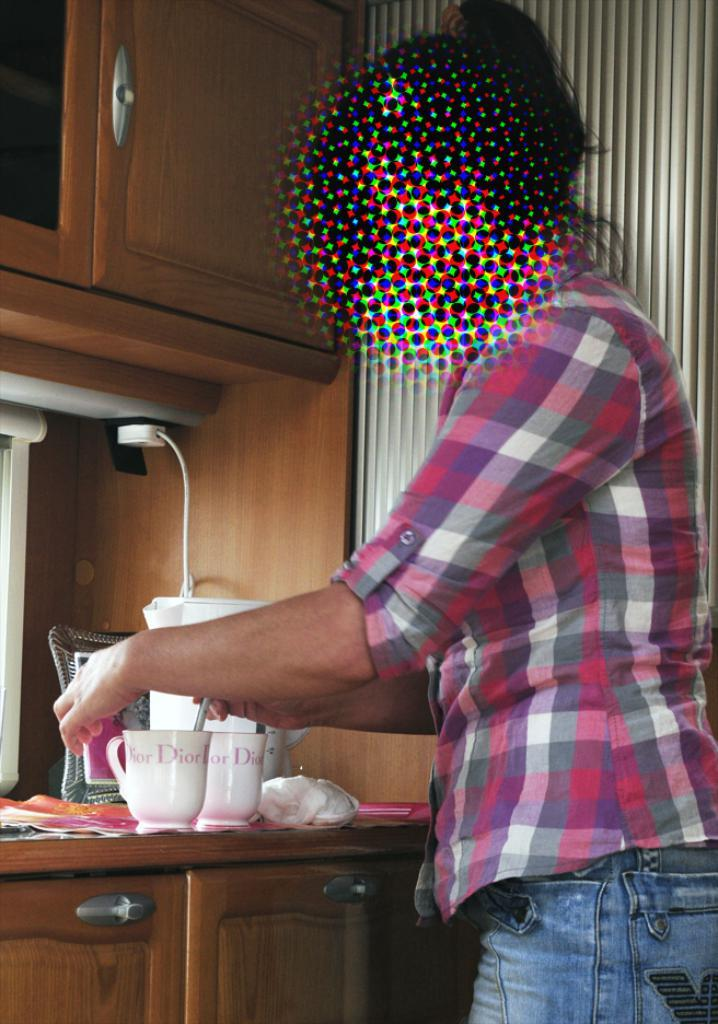Who is present in the image? There is a person in the image. What is the person wearing? The person is wearing a pink shirt. What is the person's posture in the image? The person is standing. What objects can be seen on a table in the image? There are two cups on a table in the image. How many cats are visible in the image? There are no cats present in the image. What type of card is being used by the person in the image? There is no card visible in the image. 